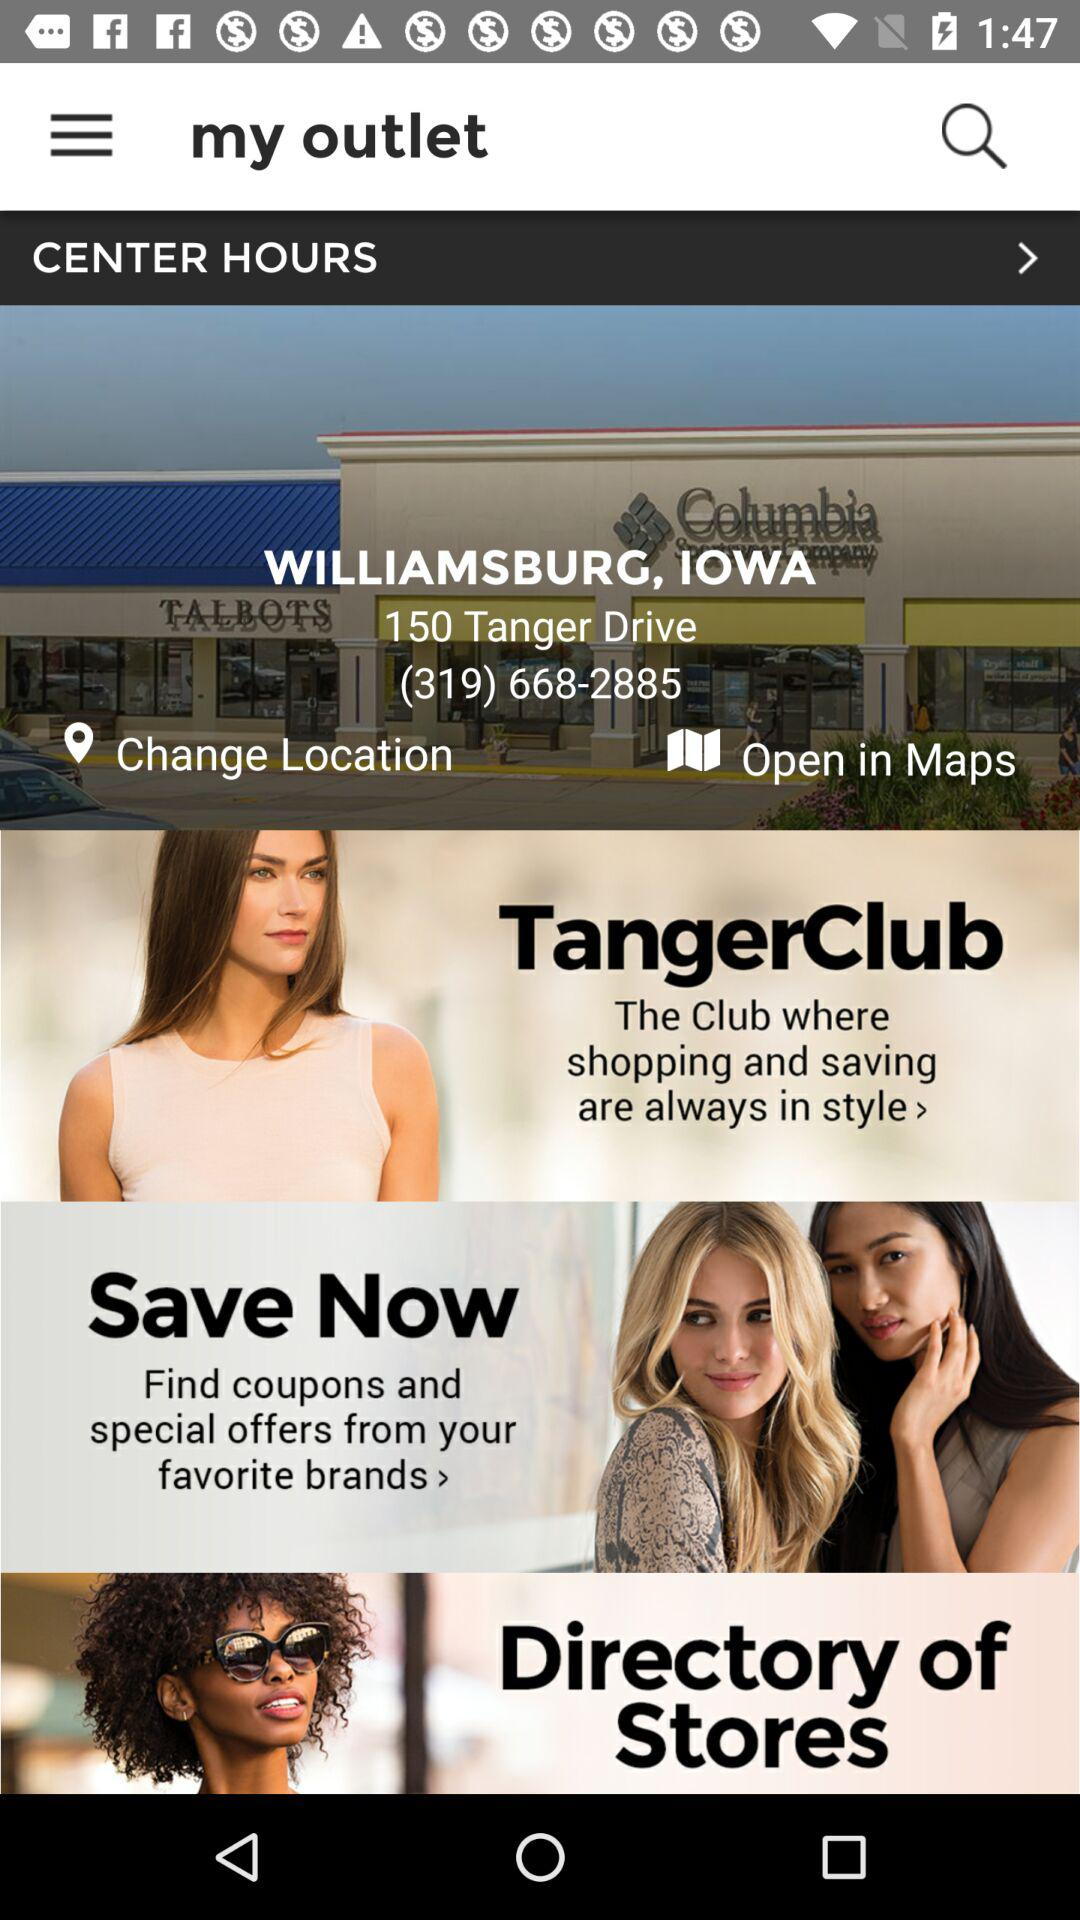Who is this application powered by?
When the provided information is insufficient, respond with <no answer>. <no answer> 